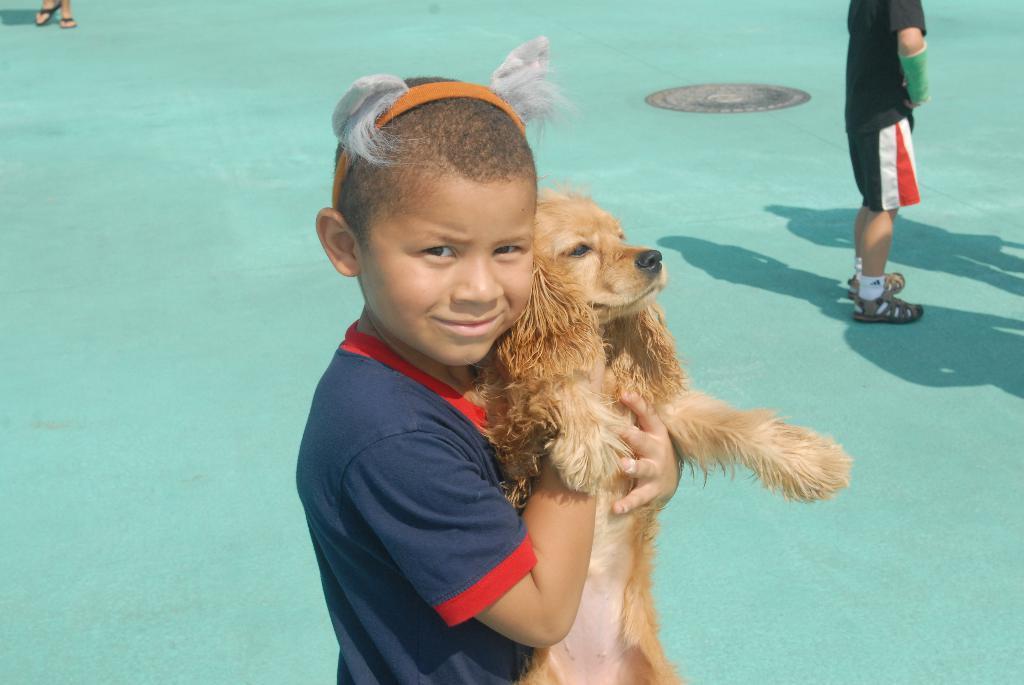Could you give a brief overview of what you see in this image? In this image I can see a person holding dog. He is wearing blue and red color dress and dog is in brown color. Back I can see a person standing and floor is in green color. 